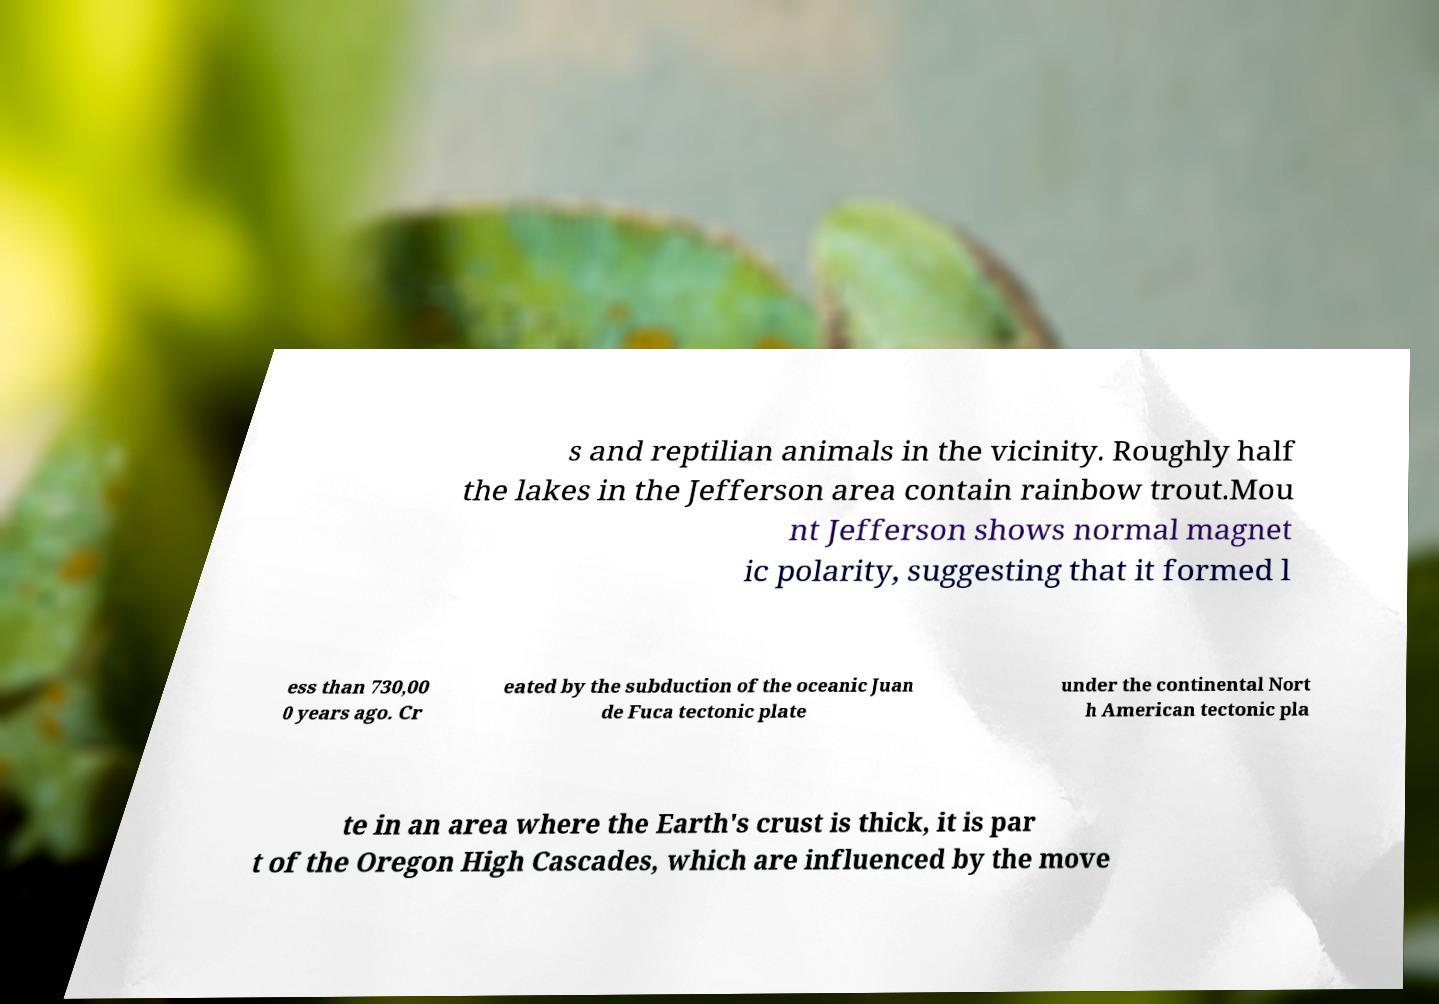There's text embedded in this image that I need extracted. Can you transcribe it verbatim? s and reptilian animals in the vicinity. Roughly half the lakes in the Jefferson area contain rainbow trout.Mou nt Jefferson shows normal magnet ic polarity, suggesting that it formed l ess than 730,00 0 years ago. Cr eated by the subduction of the oceanic Juan de Fuca tectonic plate under the continental Nort h American tectonic pla te in an area where the Earth's crust is thick, it is par t of the Oregon High Cascades, which are influenced by the move 